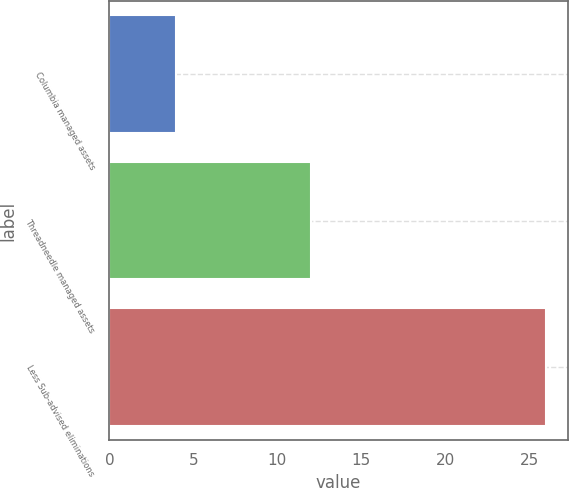<chart> <loc_0><loc_0><loc_500><loc_500><bar_chart><fcel>Columbia managed assets<fcel>Threadneedle managed assets<fcel>Less Sub-advised eliminations<nl><fcel>4<fcel>12<fcel>26<nl></chart> 